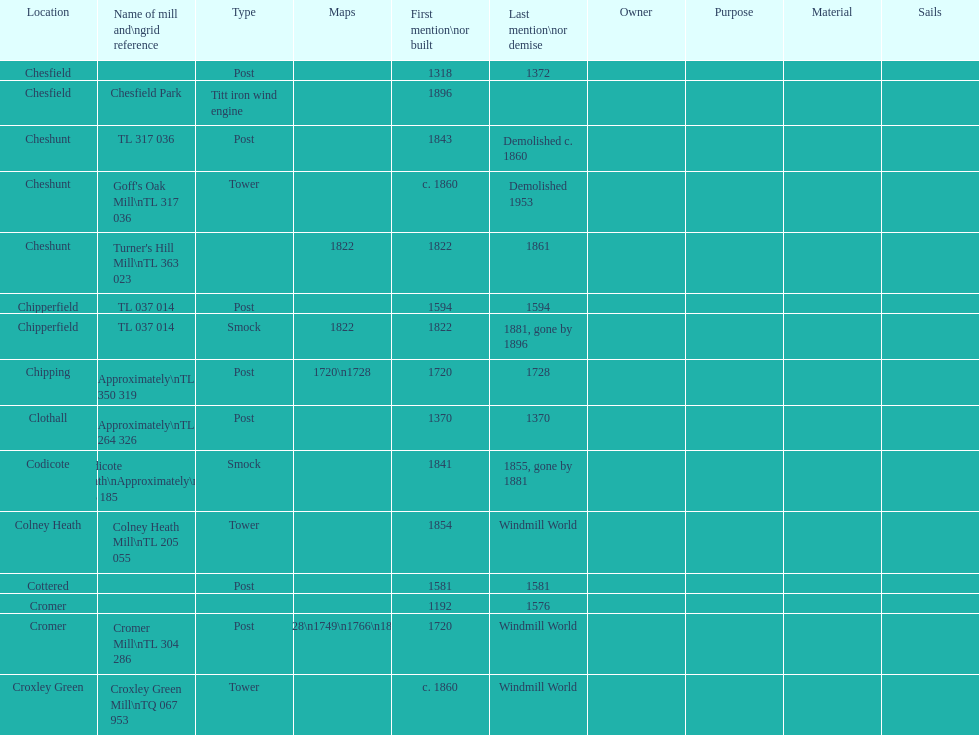How many locations have no photograph? 14. 